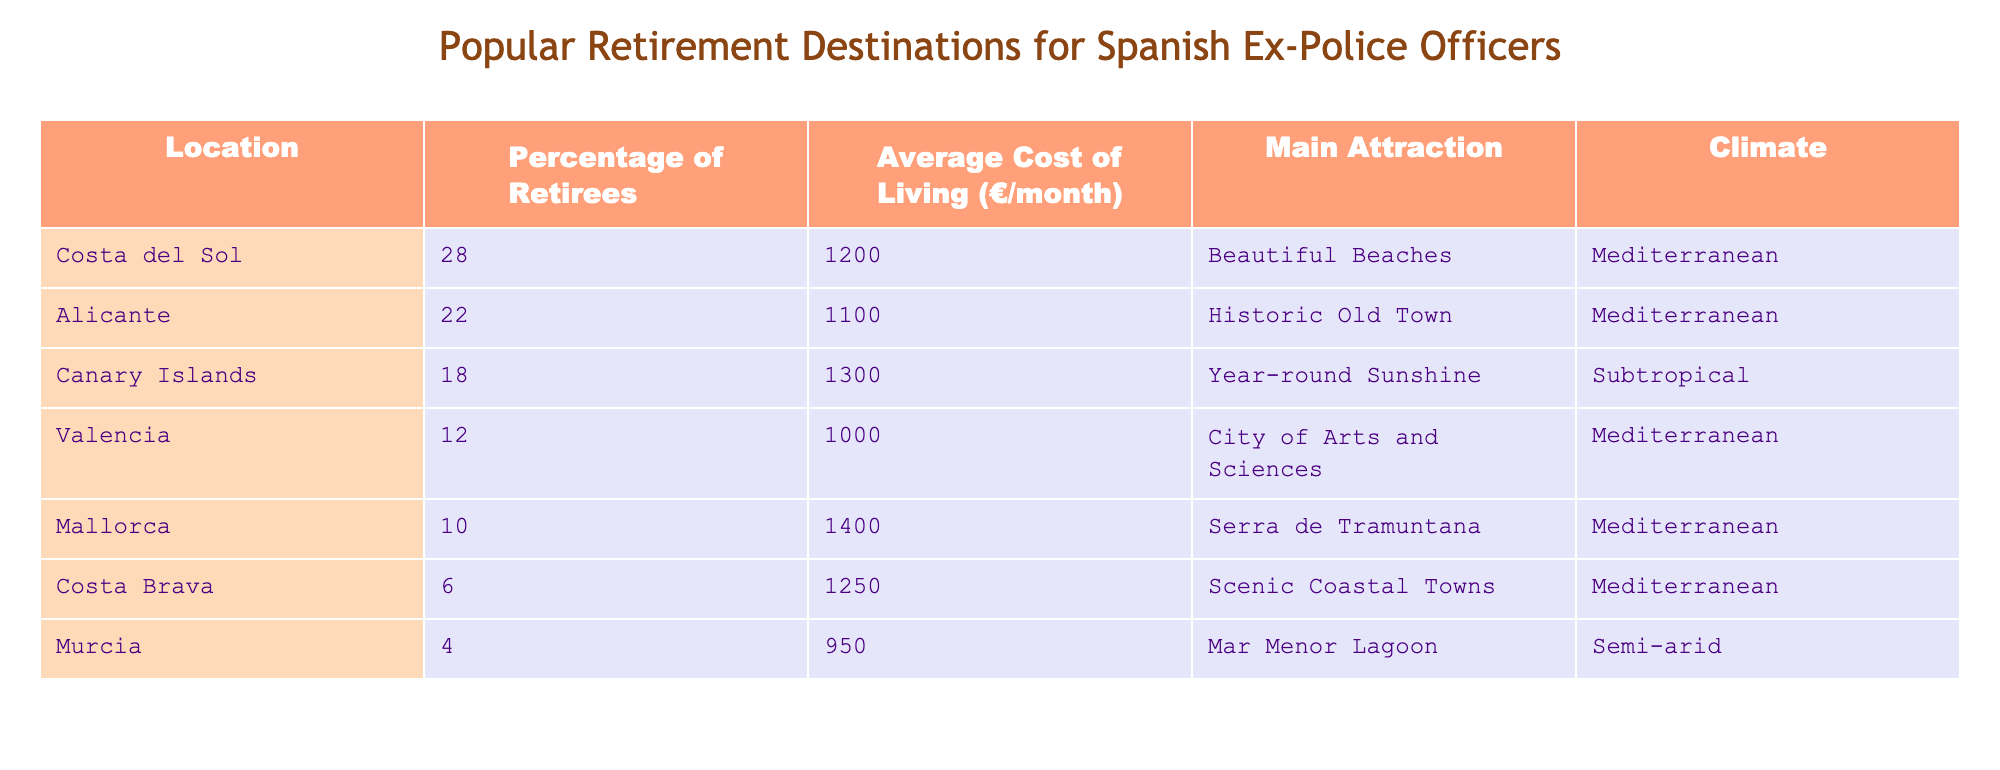What location has the highest percentage of retirees? The table lists the percentage of retirees for each location. By inspecting the "Percentage of Retirees" column, it can be seen that Costa del Sol has the highest percentage at 28%.
Answer: Costa del Sol What is the average cost of living in Alicante? The table provides the average cost of living for each location. The cost for Alicante is listed under the "Average Cost of Living (€/month)" column as 1100€.
Answer: 1100€ Which location has the main attraction of beautiful beaches? By looking at the "Main Attraction" column, it is clear that Costa del Sol is noted for its beautiful beaches.
Answer: Costa del Sol Is the average cost of living in the Canary Islands higher than in Valencia? To answer this, compare the "Average Cost of Living (€/month)" for both locations. The Canary Islands is at 1300€, while Valencia is at 1000€. Since 1300€ is greater than 1000€, the answer is yes.
Answer: Yes What is the total percentage of retirees in Costa Brava and Murcia? First, find the percentages for both locations: Costa Brava has 6% and Murcia has 4%. Then, add these values together: 6% + 4% = 10%.
Answer: 10% What percentage of retirees live in locations with a Mediterranean climate? The Mediterranean climate locations listed are Costa del Sol, Alicante, Valencia, Mallorca, and Costa Brava. Their respective percentages are 28%, 22%, 12%, 10%, and 6%. Adding these gives: 28 + 22 + 12 + 10 + 6 = 78%.
Answer: 78% Is the main attraction in Murcia a lagoon? Looking at the "Main Attraction" column, it states that the main attraction in Murcia is the Mar Menor Lagoon. Therefore, the answer is yes.
Answer: Yes Which location has the lowest average cost of living? Reviewing the "Average Cost of Living (€/month)" column, it is clear that Murcia has the lowest cost at 950€.
Answer: Murcia What is the average cost of living for the top three destinations ranked by retirees? First, identify the top three retirees' percentages: Costa del Sol (1200€), Alicante (1100€), and Canary Islands (1300€). Summing these amounts gives 1200 + 1100 + 1300 = 3600€. Then, divide by 3 for the average: 3600€ / 3 = 1200€.
Answer: 1200€ 